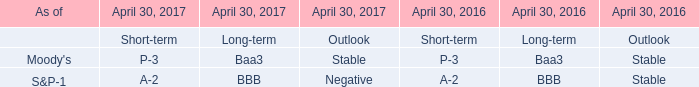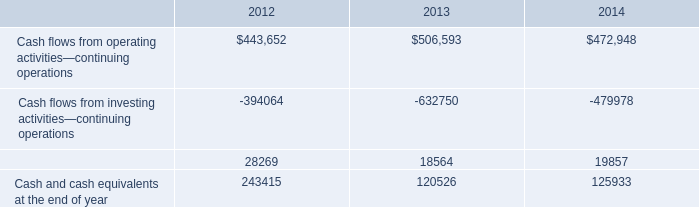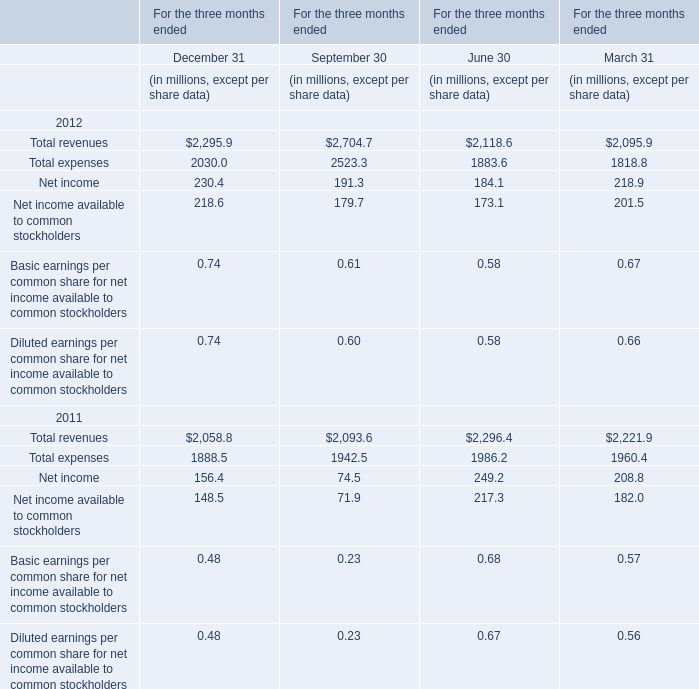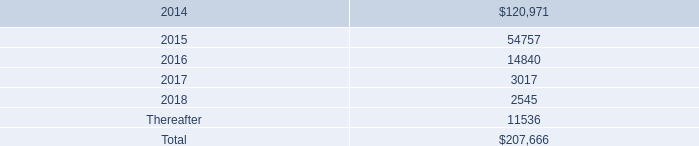How many element exceed the average of For the three months ended in 2012 forDecember 31 
Answer: 0. 